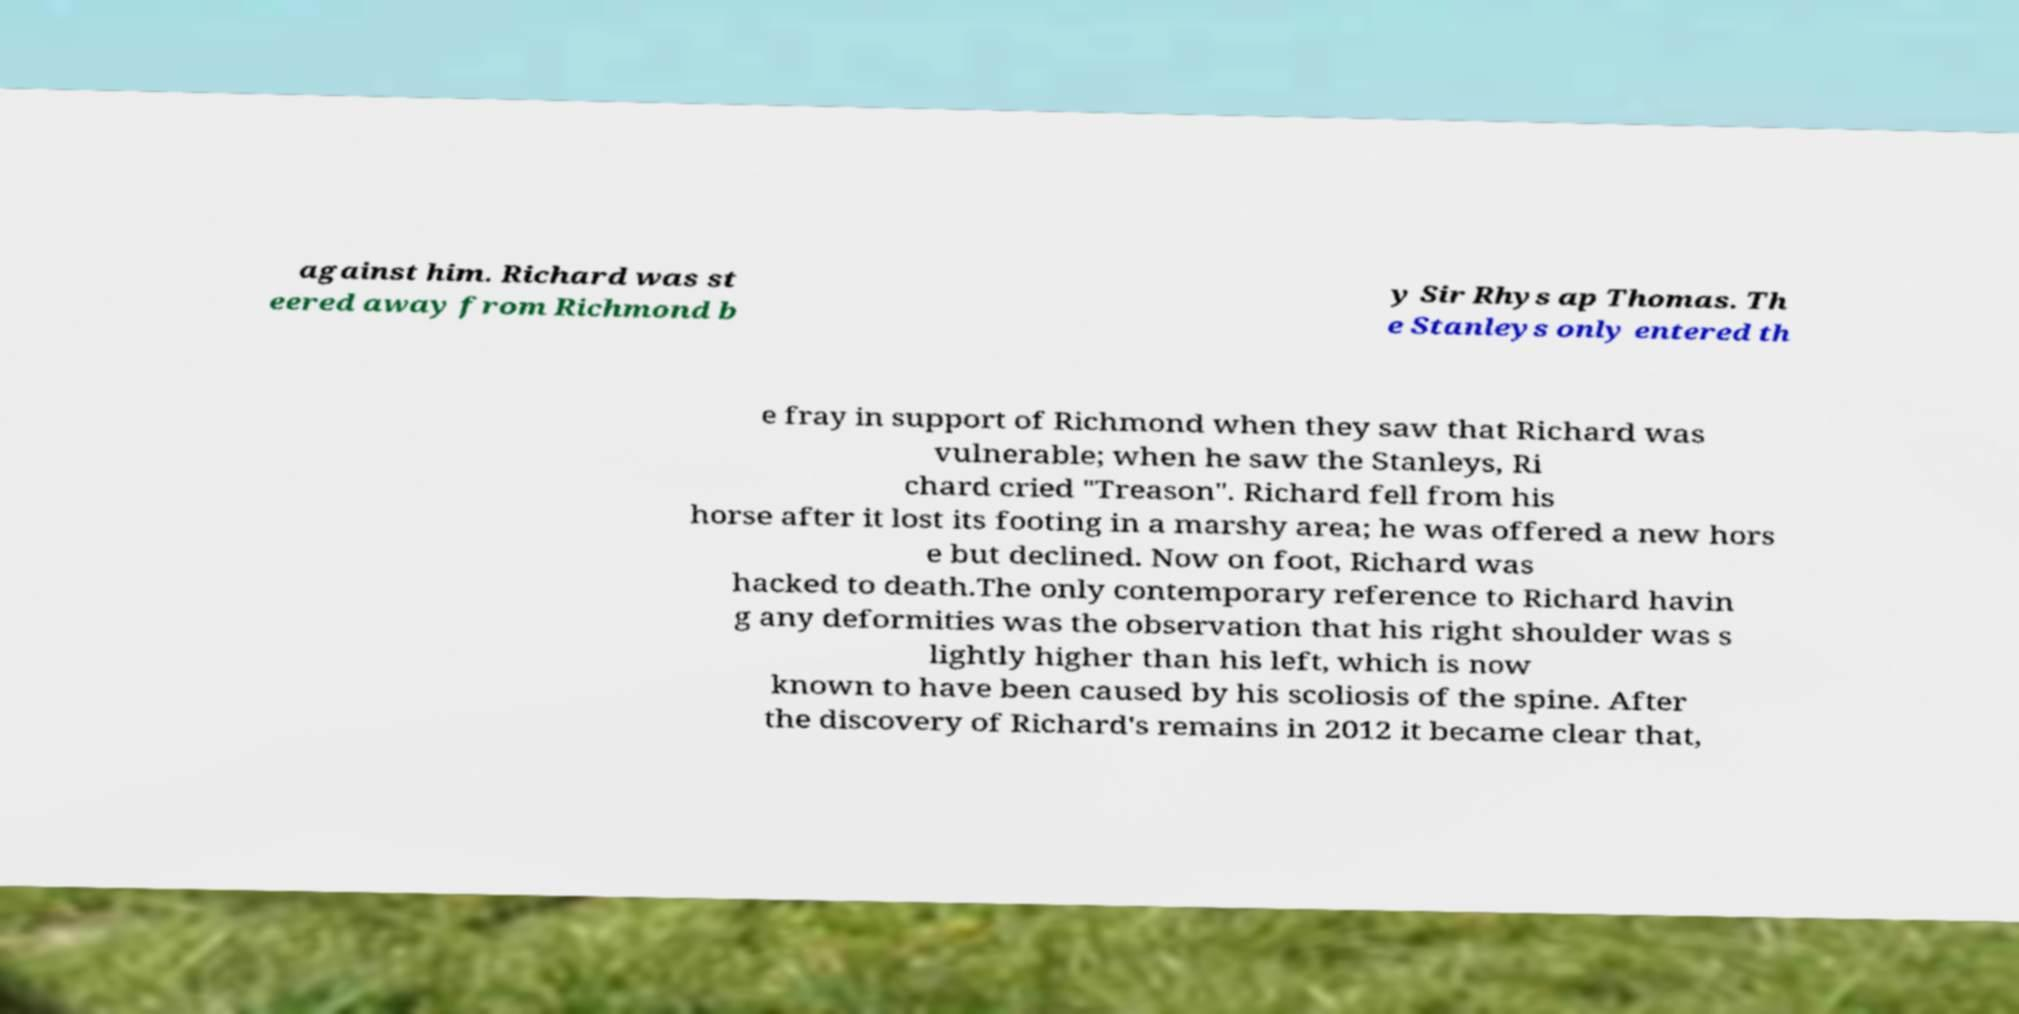What messages or text are displayed in this image? I need them in a readable, typed format. against him. Richard was st eered away from Richmond b y Sir Rhys ap Thomas. Th e Stanleys only entered th e fray in support of Richmond when they saw that Richard was vulnerable; when he saw the Stanleys, Ri chard cried "Treason". Richard fell from his horse after it lost its footing in a marshy area; he was offered a new hors e but declined. Now on foot, Richard was hacked to death.The only contemporary reference to Richard havin g any deformities was the observation that his right shoulder was s lightly higher than his left, which is now known to have been caused by his scoliosis of the spine. After the discovery of Richard's remains in 2012 it became clear that, 